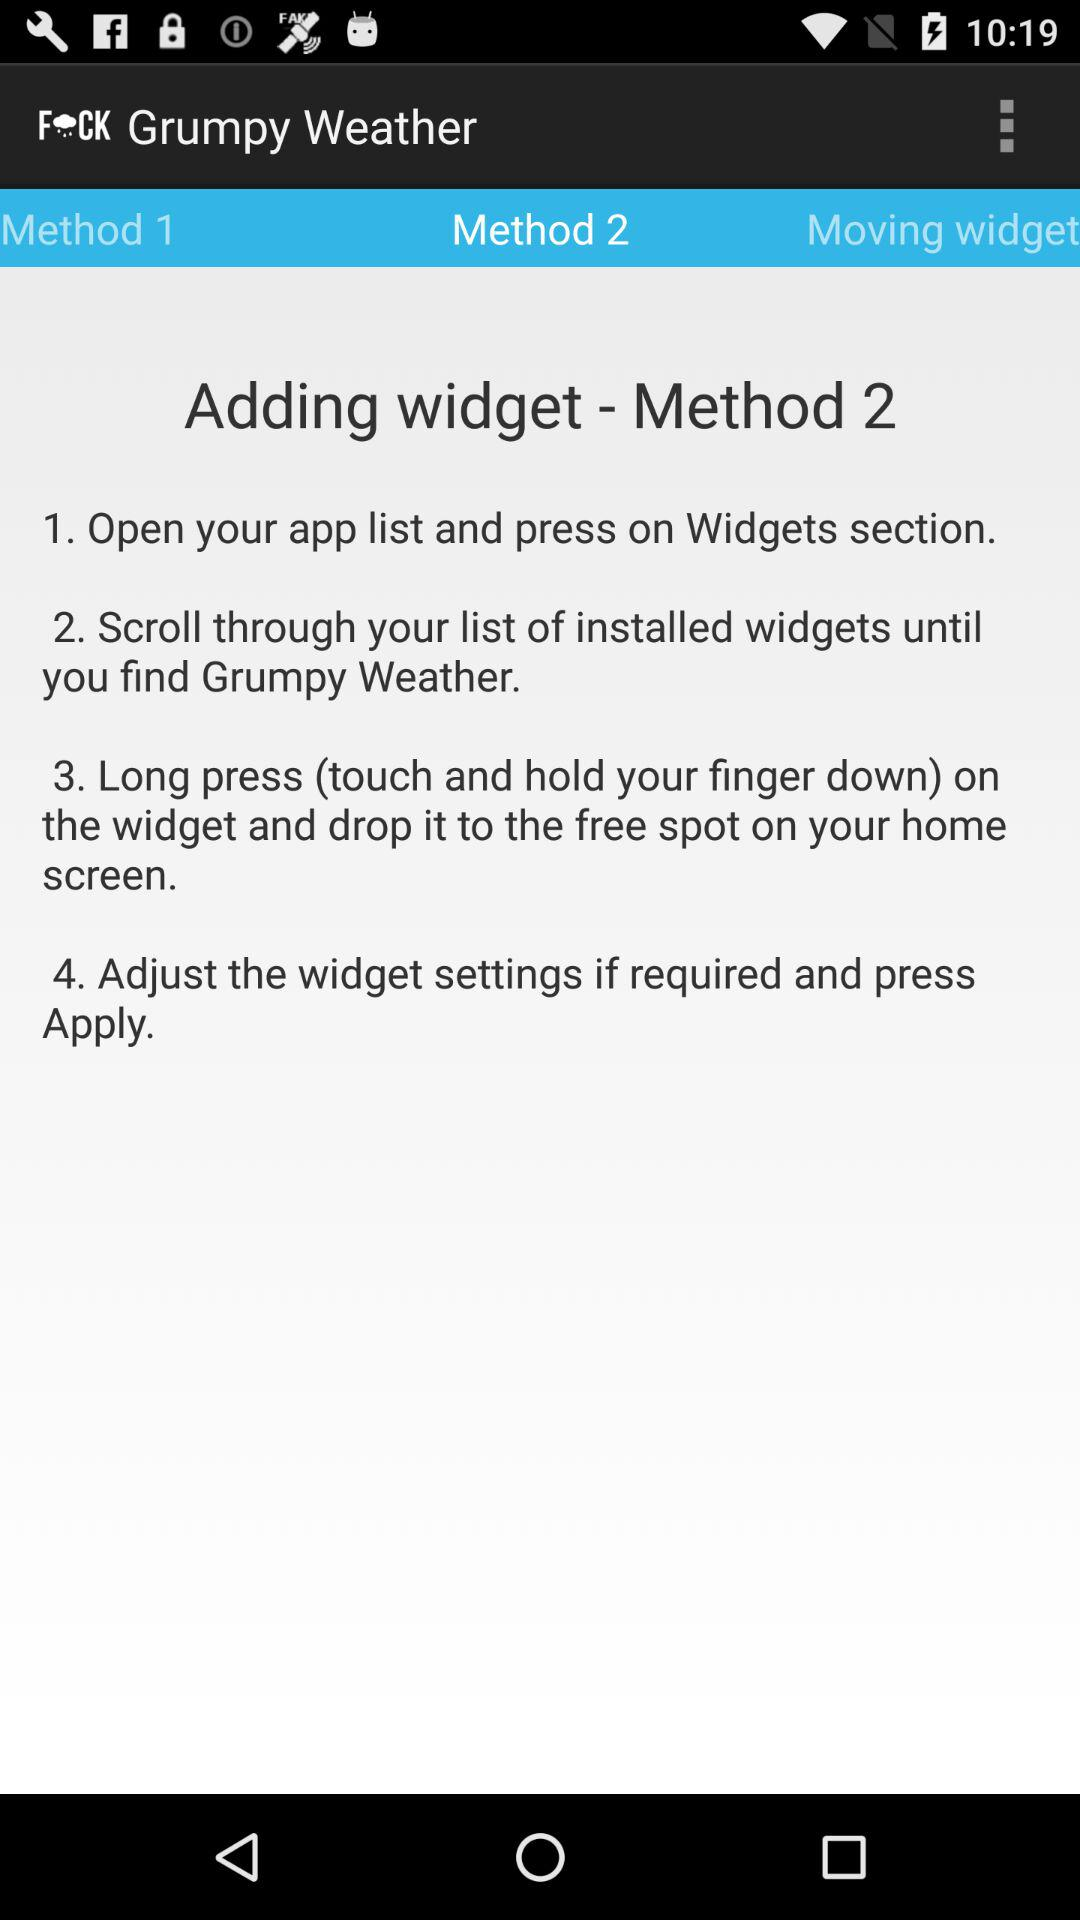What is "Method 2" of adding the widget? "Method 2" of adding the widget is: "1. Open your app list and press on Widgets section.", "2. Scroll through your list of installed widgets until you find Grumpy Weather.", "3. Long press (touch and hold your finger down) on the widget and drop it to the free spot on your home screen." and "4. Adjust the widget settings if required and press Apply.". 